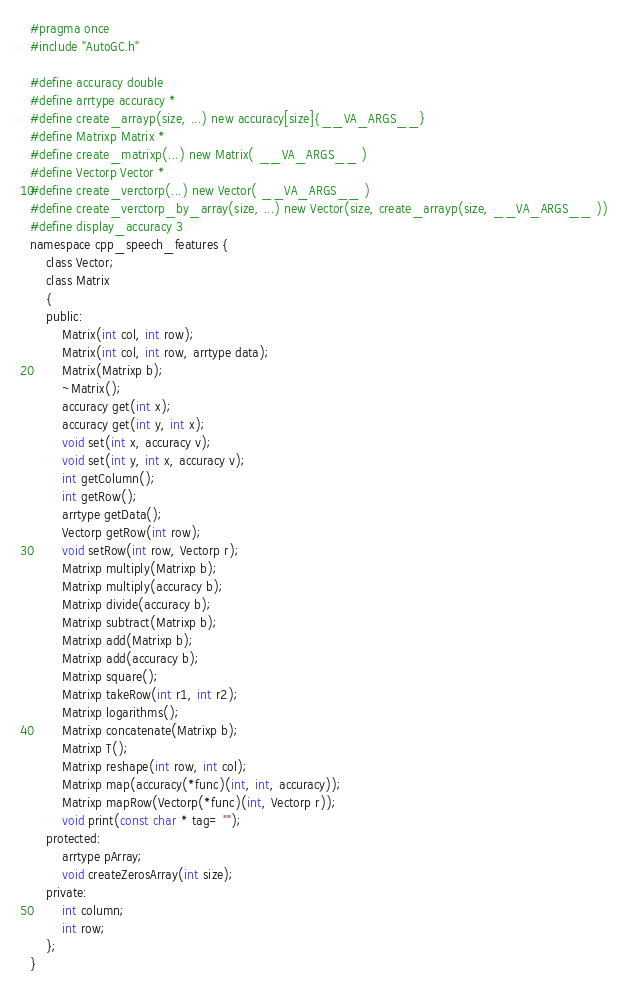<code> <loc_0><loc_0><loc_500><loc_500><_C_>#pragma once
#include "AutoGC.h"

#define accuracy double
#define arrtype accuracy *
#define create_arrayp(size, ...) new accuracy[size]{__VA_ARGS__}
#define Matrixp Matrix *
#define create_matrixp(...) new Matrix( __VA_ARGS__ )
#define Vectorp Vector *
#define create_verctorp(...) new Vector( __VA_ARGS__ )
#define create_verctorp_by_array(size, ...) new Vector(size, create_arrayp(size, __VA_ARGS__ ))
#define display_accuracy 3
namespace cpp_speech_features {
	class Vector;
	class Matrix 
	{
	public:
		Matrix(int col, int row);
		Matrix(int col, int row, arrtype data);
		Matrix(Matrixp b);
		~Matrix();
		accuracy get(int x);
		accuracy get(int y, int x);		
		void set(int x, accuracy v);
		void set(int y, int x, accuracy v);
		int getColumn();
		int getRow();
		arrtype getData();
		Vectorp getRow(int row);
		void setRow(int row, Vectorp r);
		Matrixp multiply(Matrixp b);
		Matrixp multiply(accuracy b);	
		Matrixp divide(accuracy b);	
		Matrixp subtract(Matrixp b);
		Matrixp add(Matrixp b);
		Matrixp add(accuracy b);
		Matrixp square();
		Matrixp takeRow(int r1, int r2);
		Matrixp logarithms();
		Matrixp concatenate(Matrixp b);
		Matrixp T();
		Matrixp reshape(int row, int col);			
		Matrixp map(accuracy(*func)(int, int, accuracy));
		Matrixp mapRow(Vectorp(*func)(int, Vectorp r));
		void print(const char * tag= "");
	protected:
		arrtype pArray;
		void createZerosArray(int size);
	private:	
		int column;
		int row;
	};
}

</code> 